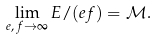Convert formula to latex. <formula><loc_0><loc_0><loc_500><loc_500>\lim _ { e , \, f \to \infty } E / ( e f ) = \mathcal { M } .</formula> 